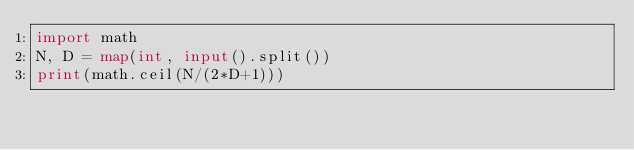<code> <loc_0><loc_0><loc_500><loc_500><_Python_>import math
N, D = map(int, input().split())
print(math.ceil(N/(2*D+1)))</code> 